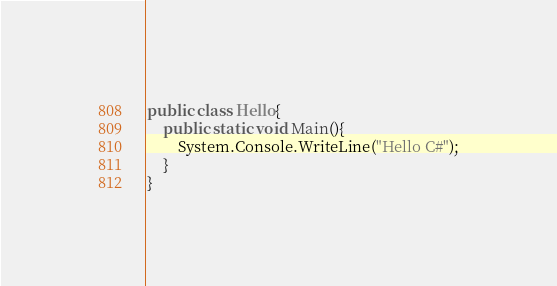Convert code to text. <code><loc_0><loc_0><loc_500><loc_500><_C#_>public class Hello{
    public static void Main(){
        System.Console.WriteLine("Hello C#");
    }
}
</code> 